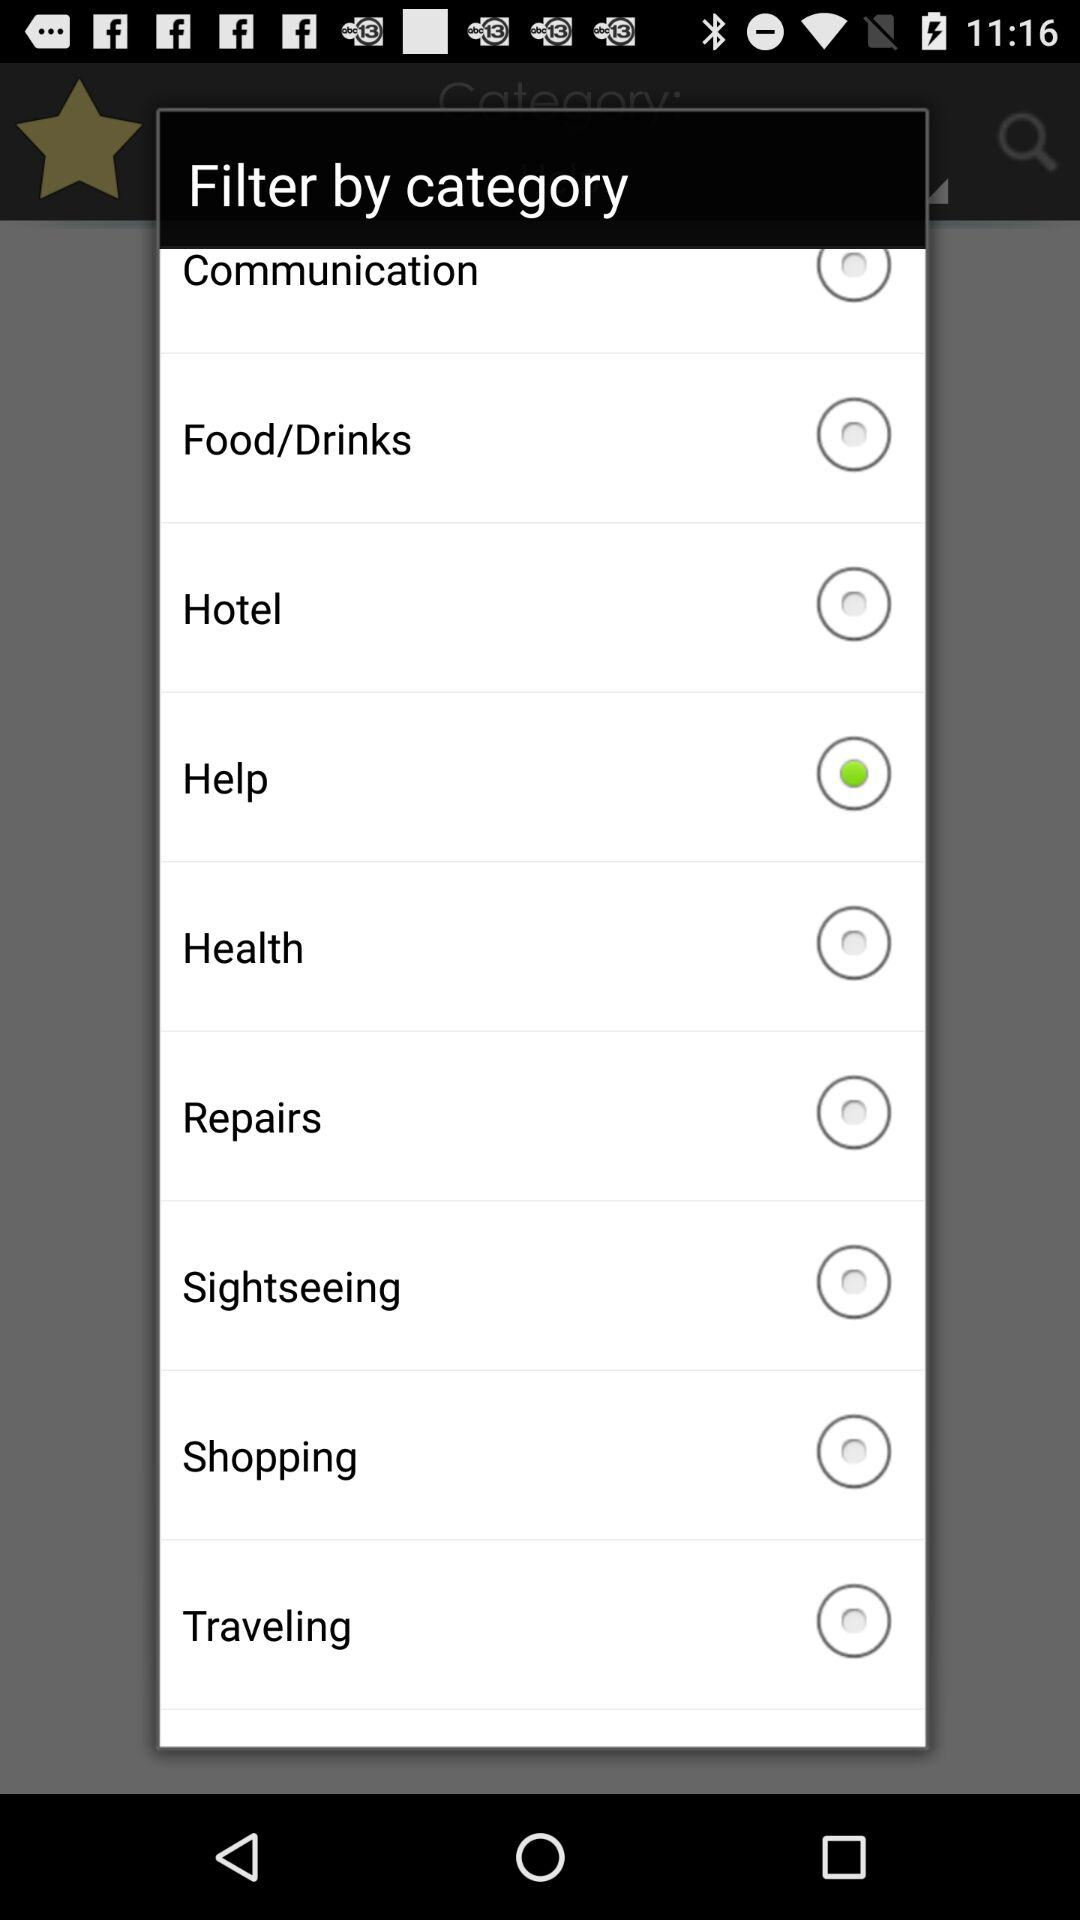Which is the selected option? The selected option is "Help". 